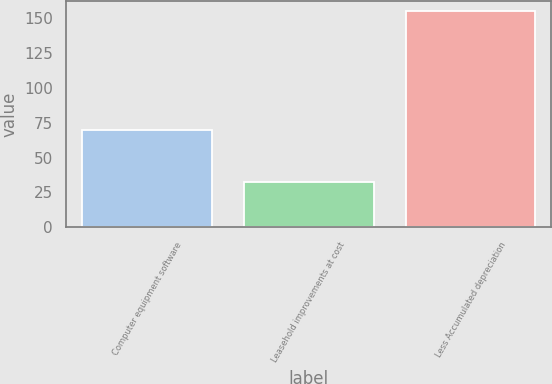Convert chart. <chart><loc_0><loc_0><loc_500><loc_500><bar_chart><fcel>Computer equipment software<fcel>Leasehold improvements at cost<fcel>Less Accumulated depreciation<nl><fcel>69.6<fcel>32.6<fcel>154.7<nl></chart> 